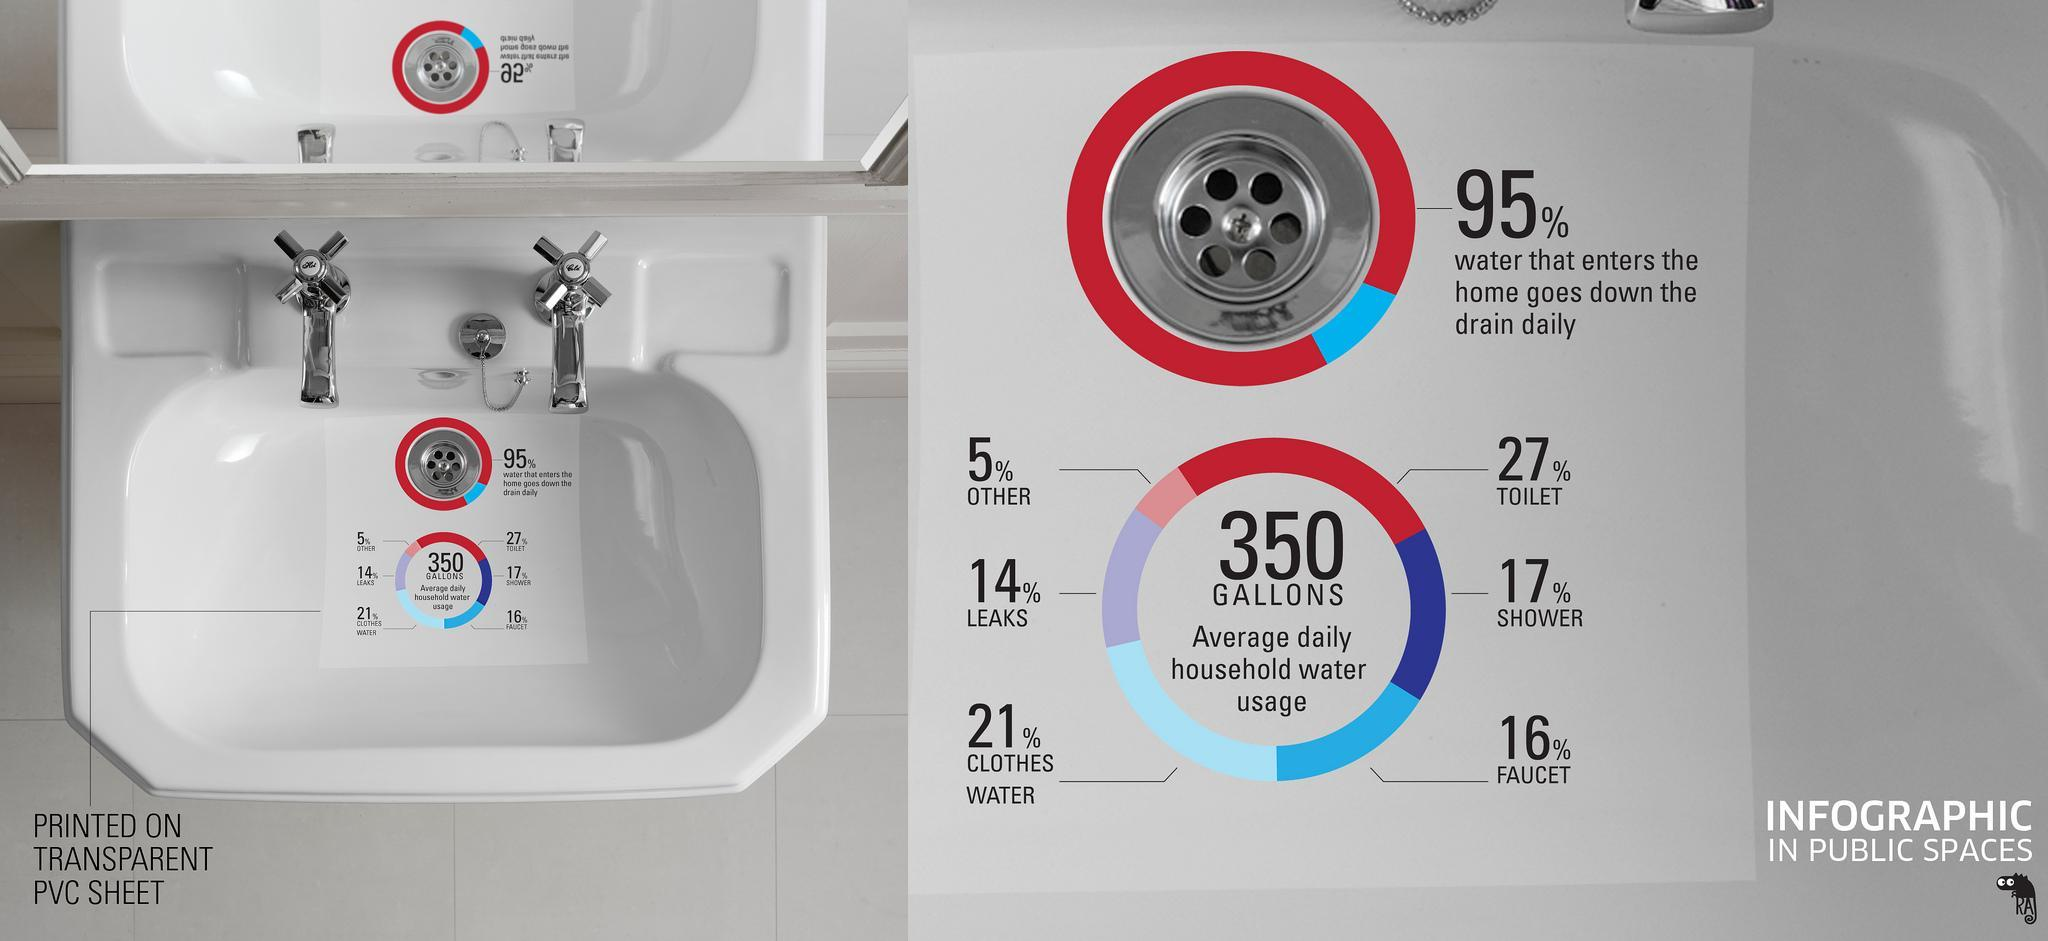Which part of home consumes the most amount of water?
Answer the question with a short phrase. Toilet 